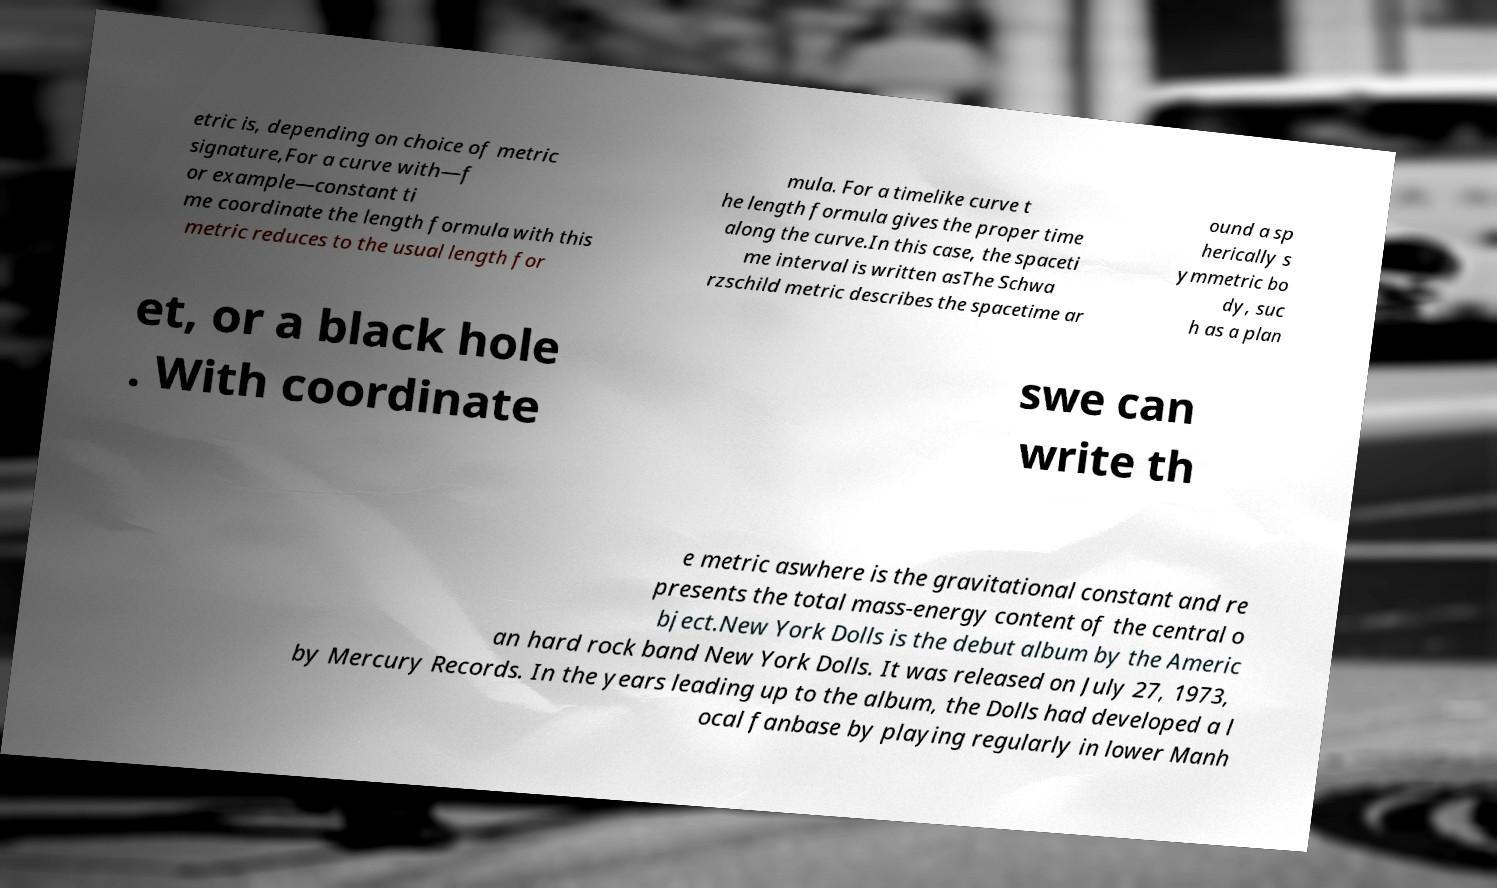I need the written content from this picture converted into text. Can you do that? etric is, depending on choice of metric signature,For a curve with—f or example—constant ti me coordinate the length formula with this metric reduces to the usual length for mula. For a timelike curve t he length formula gives the proper time along the curve.In this case, the spaceti me interval is written asThe Schwa rzschild metric describes the spacetime ar ound a sp herically s ymmetric bo dy, suc h as a plan et, or a black hole . With coordinate swe can write th e metric aswhere is the gravitational constant and re presents the total mass-energy content of the central o bject.New York Dolls is the debut album by the Americ an hard rock band New York Dolls. It was released on July 27, 1973, by Mercury Records. In the years leading up to the album, the Dolls had developed a l ocal fanbase by playing regularly in lower Manh 